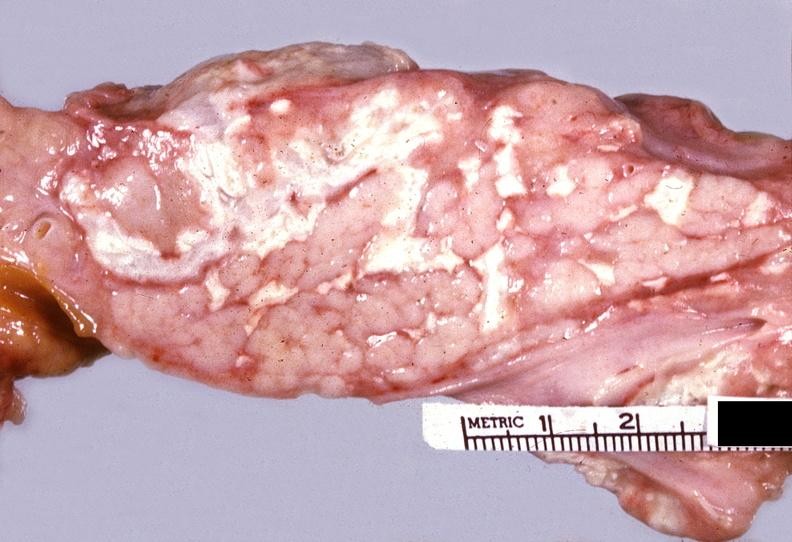does this image show acute pancreatitis?
Answer the question using a single word or phrase. Yes 